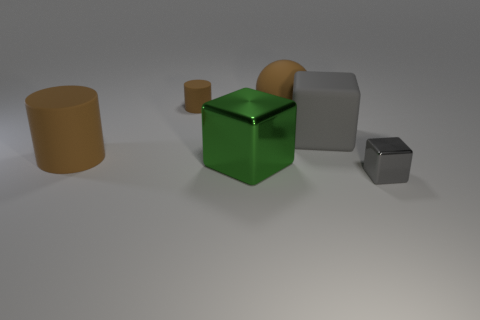How many gray blocks must be subtracted to get 1 gray blocks? 1 Add 1 large gray shiny cylinders. How many objects exist? 7 Subtract all cylinders. How many objects are left? 4 Subtract 2 brown cylinders. How many objects are left? 4 Subtract all metallic cubes. Subtract all green objects. How many objects are left? 3 Add 6 big shiny blocks. How many big shiny blocks are left? 7 Add 1 brown matte things. How many brown matte things exist? 4 